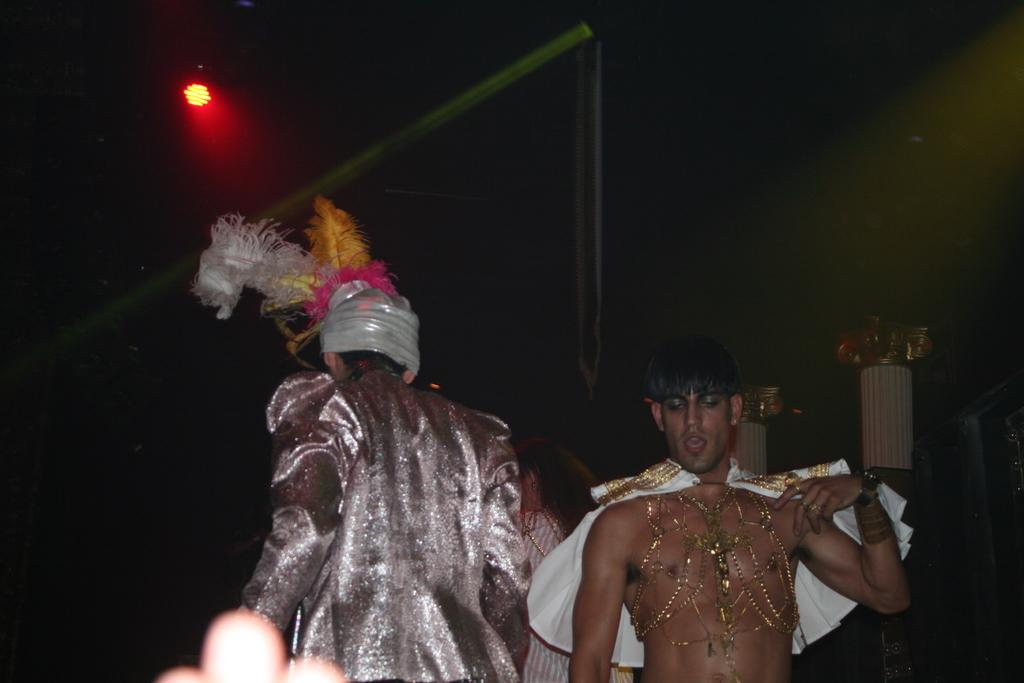How many people are in the image? There are two persons in the image. What are the persons doing in the image? The persons are standing. What are the persons wearing in the image? The persons are wearing fancy dress. What color light can be seen in the background of the image? There is a red color light in the background of the image. What type of afterthought can be seen in the image? There is no afterthought present in the image. Can you tell me how many tombstones are visible in the cemetery in the image? There is no cemetery or tombstones present in the image. 